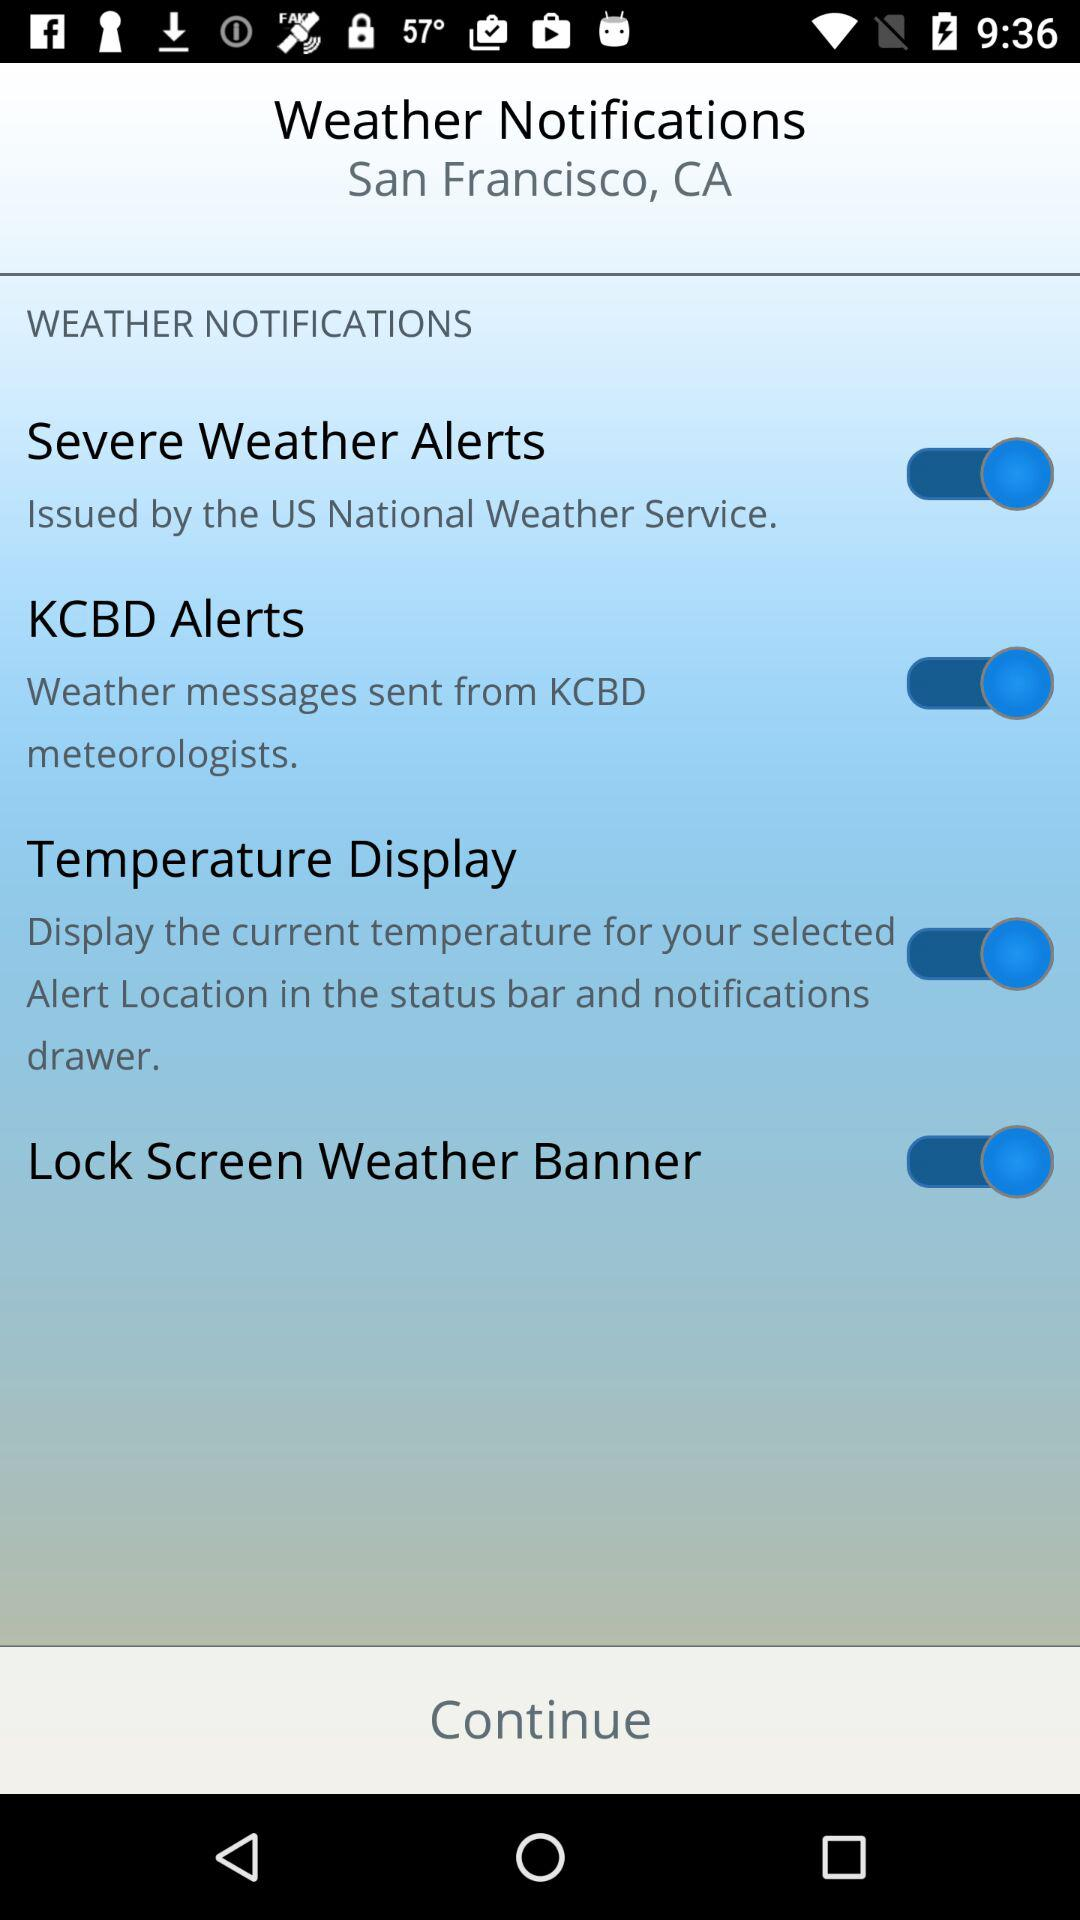For what city do the weather notifications get updated? The city is San Francisco. 